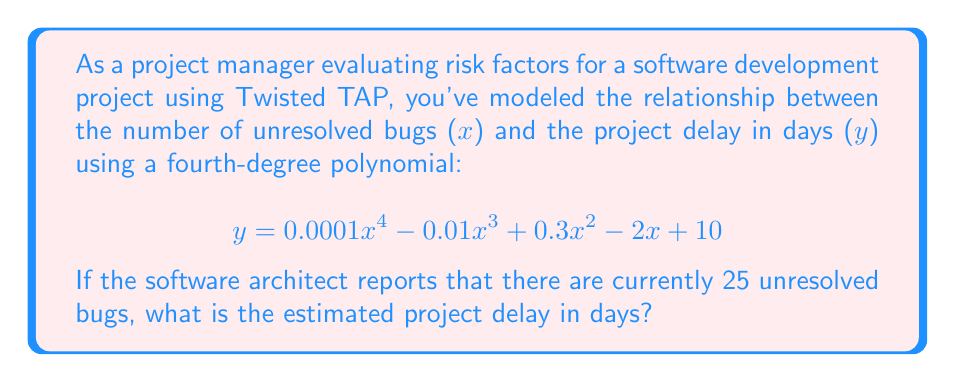Help me with this question. To solve this problem, we need to evaluate the given polynomial function at x = 25. Let's break it down step by step:

1) The polynomial function is:
   $$y = 0.0001x^4 - 0.01x^3 + 0.3x^2 - 2x + 10$$

2) We need to substitute x = 25 into this equation:
   $$y = 0.0001(25)^4 - 0.01(25)^3 + 0.3(25)^2 - 2(25) + 10$$

3) Let's evaluate each term:
   - $0.0001(25)^4 = 0.0001 * 390625 = 39.0625$
   - $-0.01(25)^3 = -0.01 * 15625 = -156.25$
   - $0.3(25)^2 = 0.3 * 625 = 187.5$
   - $-2(25) = -50$
   - The constant term is 10

4) Now, let's sum up all these terms:
   $$y = 39.0625 - 156.25 + 187.5 - 50 + 10$$

5) Calculating the final result:
   $$y = 30.3125$$

6) Since we're dealing with days, we should round to the nearest whole number:
   $$y \approx 30$$
Answer: The estimated project delay is approximately 30 days. 